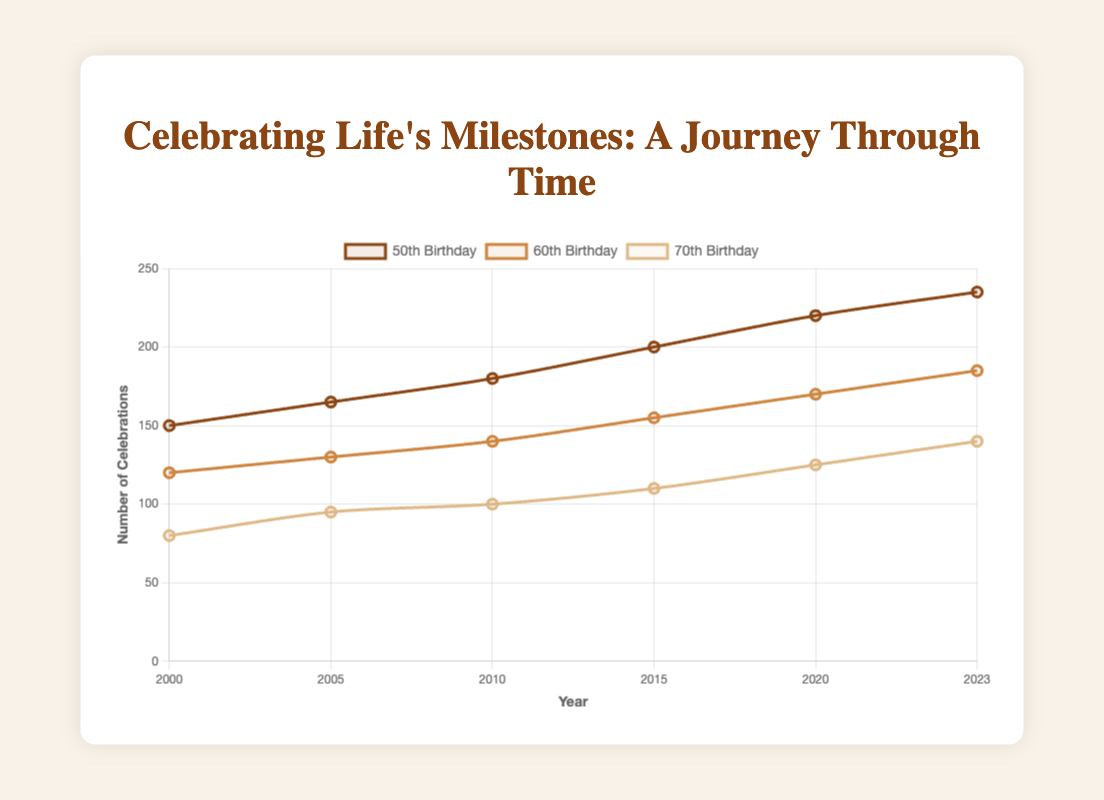Which milestone birthday had the highest number of celebrations in 2023? In the figure, locate the data point for the year 2023 on all three lines (50th, 60th, and 70th Birthday). Compare the counts for each. The 50th Birthday has the highest count.
Answer: 50th Birthday How many more celebrations were there for the 50th Birthday in 2023 compared to 2000? Find the counts for the 50th Birthday in 2023 (235) and 2000 (150). Compute the difference: 235 - 150 = 85.
Answer: 85 What is the trend for the number of celebrations for the 70th Birthday from 2000 to 2023? Examine the data points for the 70th Birthday line. Starting from 80 in 2000, it consistently increases to 140 in 2023.
Answer: Increasing Which milestone birthday saw the smallest increase in the number of celebrations between 2000 and 2023? Calculate the increase for each milestone by subtracting the 2000 count from the 2023 count. The increases are: 50th Birthday (235-150=85), 60th Birthday (185-120=65), 70th Birthday (140-80=60). The smallest increase is for the 70th Birthday.
Answer: 70th Birthday What is the average number of 60th Birthday celebrations from 2000 to 2023? Sum the counts for the 60th Birthday (120 + 130 + 140 + 155 + 170 + 185) which equals 900. There are 6 data points, so the average is 900 / 6 = 150.
Answer: 150 How did the number of 50th Birthday celebrations change from 2010 to 2015? Find the counts for the 50th Birthday in 2010 (180) and 2015 (200). The difference is 200 - 180 = 20.
Answer: Increased by 20 Which milestone birthday had the same number of celebrations in 2005 as the 50th Birthday had in 2000? The 50th Birthday had 150 celebrations in 2000. The milestone with the same count in 2005 is none; the closest values for 2005 are 165 (50th) and 130 (60th).
Answer: None By how much did the number of 60th Birthday celebrations grow between 2015 and 2020? Locate the counts for the 60th Birthday in 2015 (155) and 2020 (170). Compute the difference: 170 - 155 = 15.
Answer: 15 Which color corresponds to the line representing the 70th Birthday in the chart? The visual attribute of the 70th Birthday line is indicated by the colors provided. The color of the 70th Birthday line is light brown.
Answer: light brown 